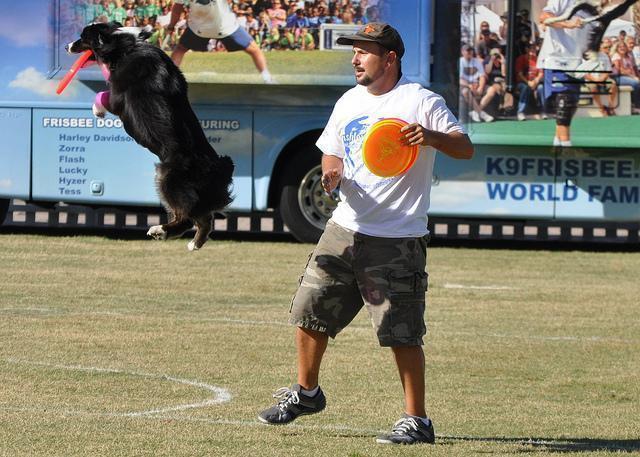Why did the dog jump in the air?
Choose the right answer and clarify with the format: 'Answer: answer
Rationale: rationale.'
Options: Eat, catch, flip, greet. Answer: catch.
Rationale: He has a frisbee in his mouth. 